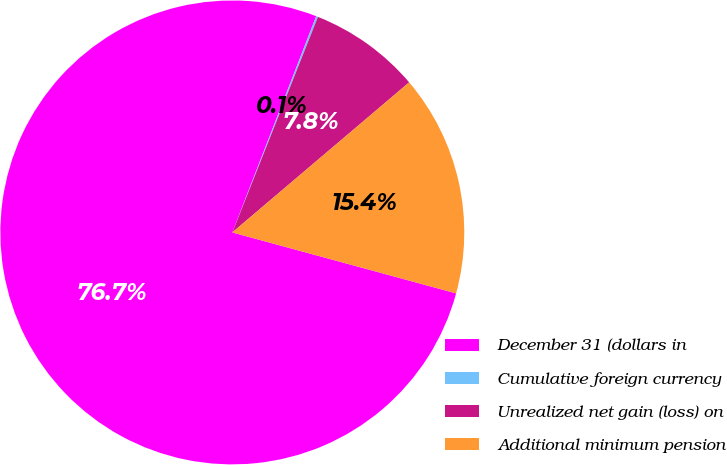Convert chart to OTSL. <chart><loc_0><loc_0><loc_500><loc_500><pie_chart><fcel>December 31 (dollars in<fcel>Cumulative foreign currency<fcel>Unrealized net gain (loss) on<fcel>Additional minimum pension<nl><fcel>76.65%<fcel>0.13%<fcel>7.78%<fcel>15.43%<nl></chart> 